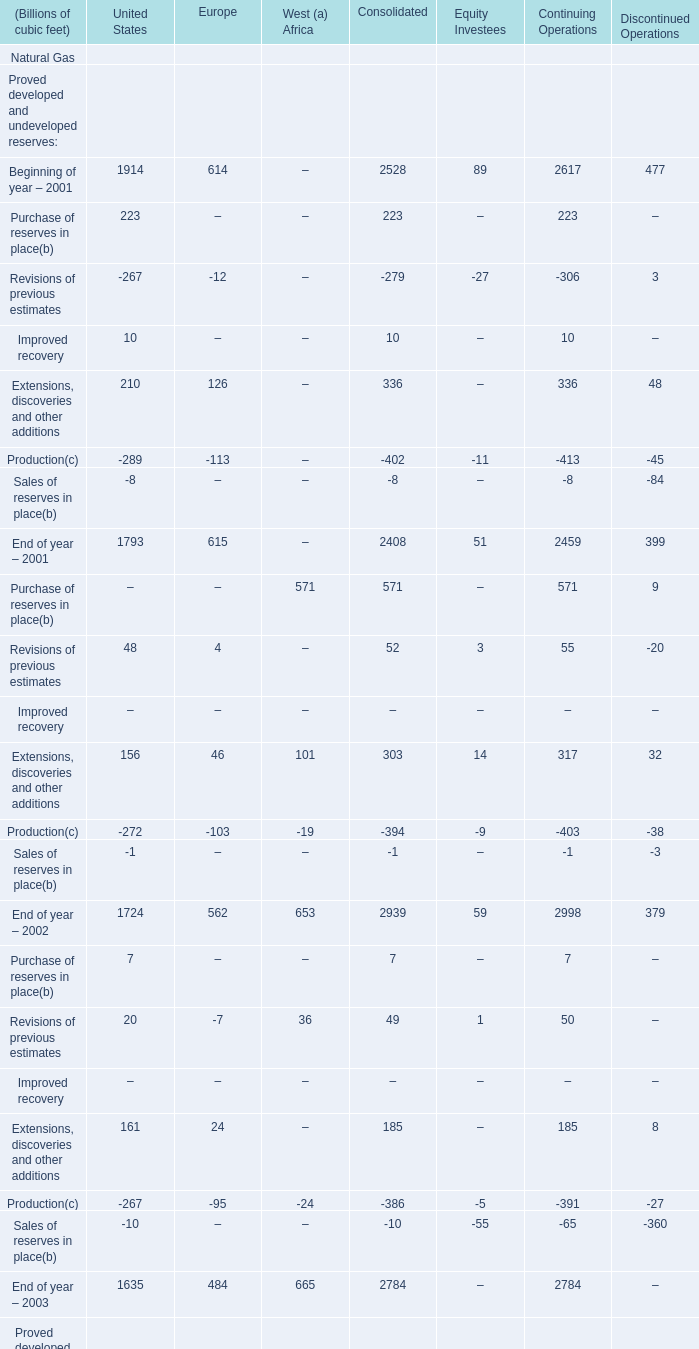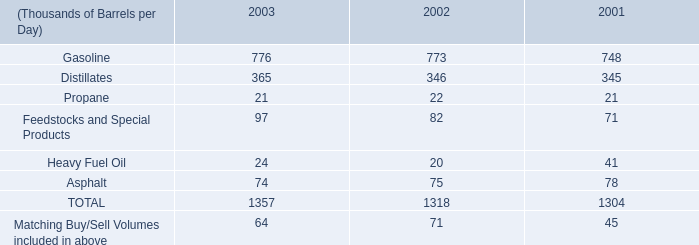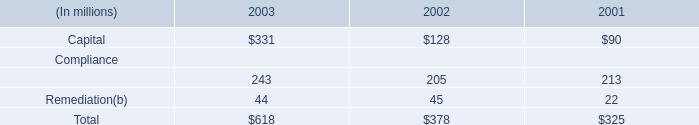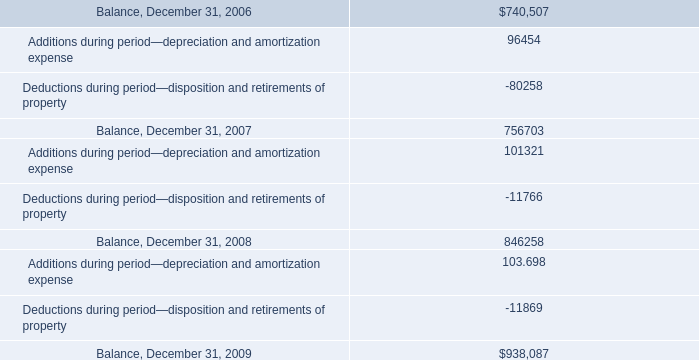what's the total amount of End of year – 2002 of United States, and Balance, December 31, 2006 ? 
Computations: (1724.0 + 740507.0)
Answer: 742231.0. 